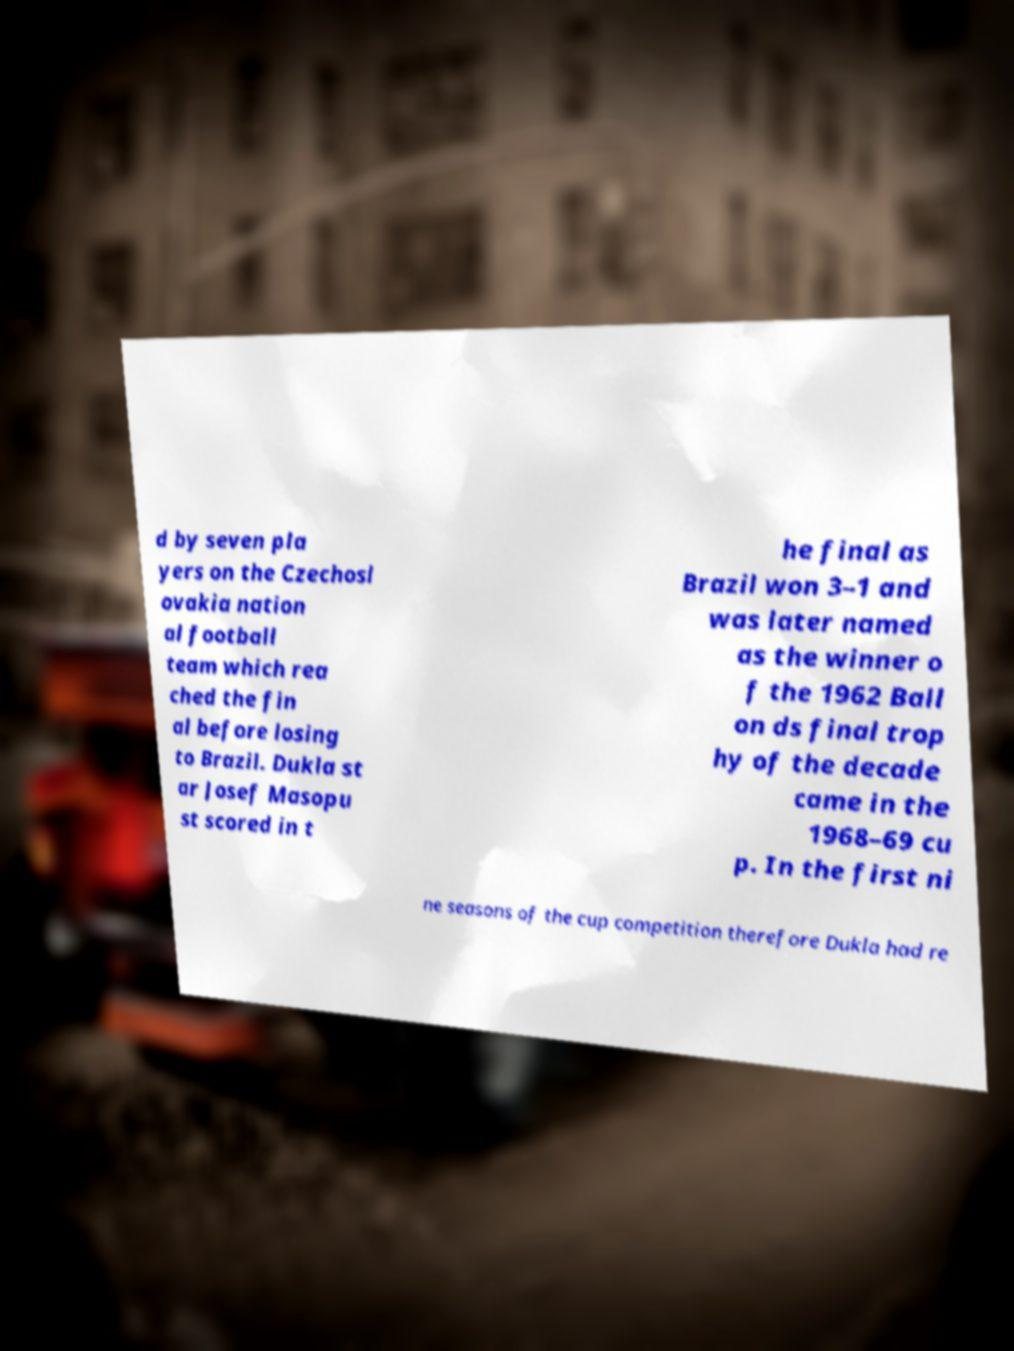I need the written content from this picture converted into text. Can you do that? d by seven pla yers on the Czechosl ovakia nation al football team which rea ched the fin al before losing to Brazil. Dukla st ar Josef Masopu st scored in t he final as Brazil won 3–1 and was later named as the winner o f the 1962 Ball on ds final trop hy of the decade came in the 1968–69 cu p. In the first ni ne seasons of the cup competition therefore Dukla had re 